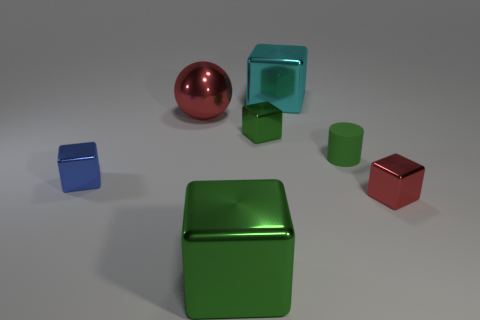What is the material of the green cube that is the same size as the blue block?
Your answer should be compact. Metal. Do the big red thing and the big cyan thing have the same material?
Provide a succinct answer. Yes. What number of balls have the same material as the tiny blue block?
Your answer should be very brief. 1. How many things are green things that are to the left of the cyan metal block or metallic objects in front of the cylinder?
Give a very brief answer. 4. Is the number of tiny green rubber things behind the blue shiny object greater than the number of small red shiny cubes in front of the tiny red shiny object?
Keep it short and to the point. Yes. What color is the large shiny thing to the right of the small green shiny block?
Provide a succinct answer. Cyan. Is there a cyan metal object that has the same shape as the blue thing?
Offer a very short reply. Yes. What number of red objects are either small rubber objects or big metallic cylinders?
Your answer should be very brief. 0. Are there any blue cylinders that have the same size as the cyan shiny cube?
Provide a short and direct response. No. What number of big green rubber balls are there?
Ensure brevity in your answer.  0. 